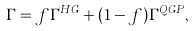<formula> <loc_0><loc_0><loc_500><loc_500>\Gamma = f \Gamma ^ { H G } + ( 1 - f ) \Gamma ^ { Q G P } ,</formula> 